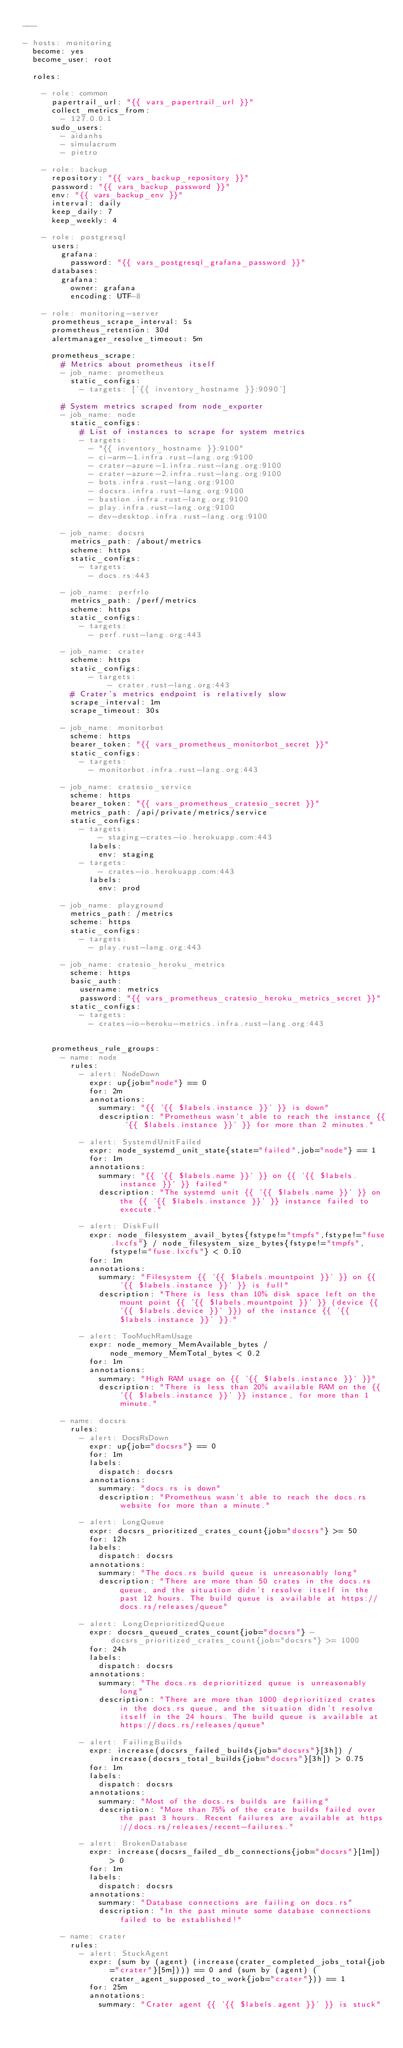Convert code to text. <code><loc_0><loc_0><loc_500><loc_500><_YAML_>---

- hosts: monitoring
  become: yes
  become_user: root

  roles:

    - role: common
      papertrail_url: "{{ vars_papertrail_url }}"
      collect_metrics_from:
        - 127.0.0.1
      sudo_users:
        - aidanhs
        - simulacrum
        - pietro

    - role: backup
      repository: "{{ vars_backup_repository }}"
      password: "{{ vars_backup_password }}"
      env: "{{ vars_backup_env }}"
      interval: daily
      keep_daily: 7
      keep_weekly: 4

    - role: postgresql
      users:
        grafana:
          password: "{{ vars_postgresql_grafana_password }}"
      databases:
        grafana:
          owner: grafana
          encoding: UTF-8

    - role: monitoring-server
      prometheus_scrape_interval: 5s
      prometheus_retention: 30d
      alertmanager_resolve_timeout: 5m

      prometheus_scrape:
        # Metrics about prometheus itself
        - job_name: prometheus
          static_configs:
            - targets: ['{{ inventory_hostname }}:9090']

        # System metrics scraped from node_exporter
        - job_name: node
          static_configs:
            # List of instances to scrape for system metrics
            - targets:
              - "{{ inventory_hostname }}:9100"
              - ci-arm-1.infra.rust-lang.org:9100
              - crater-azure-1.infra.rust-lang.org:9100
              - crater-azure-2.infra.rust-lang.org:9100
              - bots.infra.rust-lang.org:9100
              - docsrs.infra.rust-lang.org:9100
              - bastion.infra.rust-lang.org:9100
              - play.infra.rust-lang.org:9100
              - dev-desktop.infra.rust-lang.org:9100

        - job_name: docsrs
          metrics_path: /about/metrics
          scheme: https
          static_configs:
            - targets:
              - docs.rs:443

        - job_name: perfrlo
          metrics_path: /perf/metrics
          scheme: https
          static_configs:
            - targets:
              - perf.rust-lang.org:443

        - job_name: crater
          scheme: https
          static_configs:
              - targets:
                  - crater.rust-lang.org:443
          # Crater's metrics endpoint is relatively slow
          scrape_interval: 1m
          scrape_timeout: 30s

        - job_name: monitorbot
          scheme: https
          bearer_token: "{{ vars_prometheus_monitorbot_secret }}"
          static_configs:
            - targets:
              - monitorbot.infra.rust-lang.org:443

        - job_name: cratesio_service
          scheme: https
          bearer_token: "{{ vars_prometheus_cratesio_secret }}"
          metrics_path: /api/private/metrics/service
          static_configs:
            - targets:
                - staging-crates-io.herokuapp.com:443
              labels:
                env: staging
            - targets:
                - crates-io.herokuapp.com:443
              labels:
                env: prod

        - job_name: playground
          metrics_path: /metrics
          scheme: https
          static_configs:
            - targets:
              - play.rust-lang.org:443

        - job_name: cratesio_heroku_metrics
          scheme: https
          basic_auth:
            username: metrics
            password: "{{ vars_prometheus_cratesio_heroku_metrics_secret }}"
          static_configs:
            - targets:
              - crates-io-heroku-metrics.infra.rust-lang.org:443


      prometheus_rule_groups:
        - name: node
          rules:
            - alert: NodeDown
              expr: up{job="node"} == 0
              for: 2m
              annotations:
                summary: "{{ '{{ $labels.instance }}' }} is down"
                description: "Prometheus wasn't able to reach the instance {{ '{{ $labels.instance }}' }} for more than 2 minutes."

            - alert: SystemdUnitFailed
              expr: node_systemd_unit_state{state="failed",job="node"} == 1
              for: 1m
              annotations:
                summary: "{{ '{{ $labels.name }}' }} on {{ '{{ $labels.instance }}' }} failed"
                description: "The systemd unit {{ '{{ $labels.name }}' }} on the {{ '{{ $labels.instance }}' }} instance failed to execute."

            - alert: DiskFull
              expr: node_filesystem_avail_bytes{fstype!="tmpfs",fstype!="fuse.lxcfs"} / node_filesystem_size_bytes{fstype!="tmpfs",fstype!="fuse.lxcfs"} < 0.10
              for: 1m
              annotations:
                summary: "Filesystem {{ '{{ $labels.mountpoint }}' }} on {{ '{{ $labels.instance }}' }} is full"
                description: "There is less than 10% disk space left on the mount point {{ '{{ $labels.mountpoint }}' }} (device {{ '{{ $labels.device }}' }}) of the instance {{ '{{ $labels.instance }}' }}."

            - alert: TooMuchRamUsage
              expr: node_memory_MemAvailable_bytes / node_memory_MemTotal_bytes < 0.2
              for: 1m
              annotations:
                summary: "High RAM usage on {{ '{{ $labels.instance }}' }}"
                description: "There is less than 20% available RAM on the {{ '{{ $labels.instance }}' }} instance, for more than 1 minute."

        - name: docsrs
          rules:
            - alert: DocsRsDown
              expr: up{job="docsrs"} == 0
              for: 1m
              labels:
                dispatch: docsrs
              annotations:
                summary: "docs.rs is down"
                description: "Prometheus wasn't able to reach the docs.rs website for more than a minute."

            - alert: LongQueue
              expr: docsrs_prioritized_crates_count{job="docsrs"} >= 50
              for: 12h
              labels:
                dispatch: docsrs
              annotations:
                summary: "The docs.rs build queue is unreasonably long"
                description: "There are more than 50 crates in the docs.rs queue, and the situation didn't resolve itself in the past 12 hours. The build queue is available at https://docs.rs/releases/queue"

            - alert: LongDeprioritizedQueue
              expr: docsrs_queued_crates_count{job="docsrs"} - docsrs_prioritized_crates_count{job="docsrs"} >= 1000
              for: 24h
              labels:
                dispatch: docsrs
              annotations:
                summary: "The docs.rs deprioritized queue is unreasonably long"
                description: "There are more than 1000 deprioritized crates in the docs.rs queue, and the situation didn't resolve itself in the 24 hours. The build queue is available at https://docs.rs/releases/queue"

            - alert: FailingBuilds
              expr: increase(docsrs_failed_builds{job="docsrs"}[3h]) / increase(docsrs_total_builds{job="docsrs"}[3h]) > 0.75
              for: 1m
              labels:
                dispatch: docsrs
              annotations:
                summary: "Most of the docs.rs builds are failing"
                description: "More than 75% of the crate builds failed over the past 3 hours. Recent failures are available at https://docs.rs/releases/recent-failures."

            - alert: BrokenDatabase
              expr: increase(docsrs_failed_db_connections{job="docsrs"}[1m]) > 0
              for: 1m
              labels:
                dispatch: docsrs
              annotations:
                summary: "Database connections are failing on docs.rs"
                description: "In the past minute some database connections failed to be established!"

        - name: crater
          rules:
            - alert: StuckAgent
              expr: (sum by (agent) (increase(crater_completed_jobs_total{job="crater"}[5m]))) == 0 and (sum by (agent) (crater_agent_supposed_to_work{job="crater"})) == 1
              for: 25m
              annotations:
                summary: "Crater agent {{ '{{ $labels.agent }}' }} is stuck"</code> 